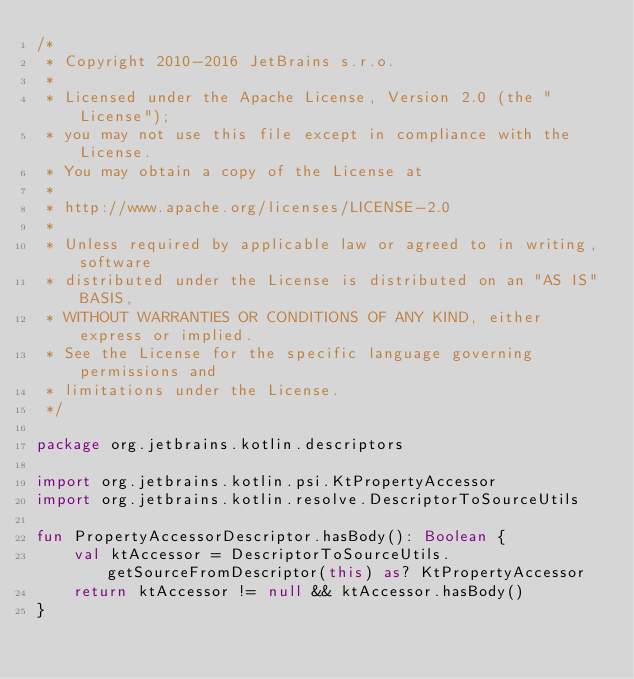<code> <loc_0><loc_0><loc_500><loc_500><_Kotlin_>/*
 * Copyright 2010-2016 JetBrains s.r.o.
 *
 * Licensed under the Apache License, Version 2.0 (the "License");
 * you may not use this file except in compliance with the License.
 * You may obtain a copy of the License at
 *
 * http://www.apache.org/licenses/LICENSE-2.0
 *
 * Unless required by applicable law or agreed to in writing, software
 * distributed under the License is distributed on an "AS IS" BASIS,
 * WITHOUT WARRANTIES OR CONDITIONS OF ANY KIND, either express or implied.
 * See the License for the specific language governing permissions and
 * limitations under the License.
 */

package org.jetbrains.kotlin.descriptors

import org.jetbrains.kotlin.psi.KtPropertyAccessor
import org.jetbrains.kotlin.resolve.DescriptorToSourceUtils

fun PropertyAccessorDescriptor.hasBody(): Boolean {
    val ktAccessor = DescriptorToSourceUtils.getSourceFromDescriptor(this) as? KtPropertyAccessor
    return ktAccessor != null && ktAccessor.hasBody()
}
</code> 